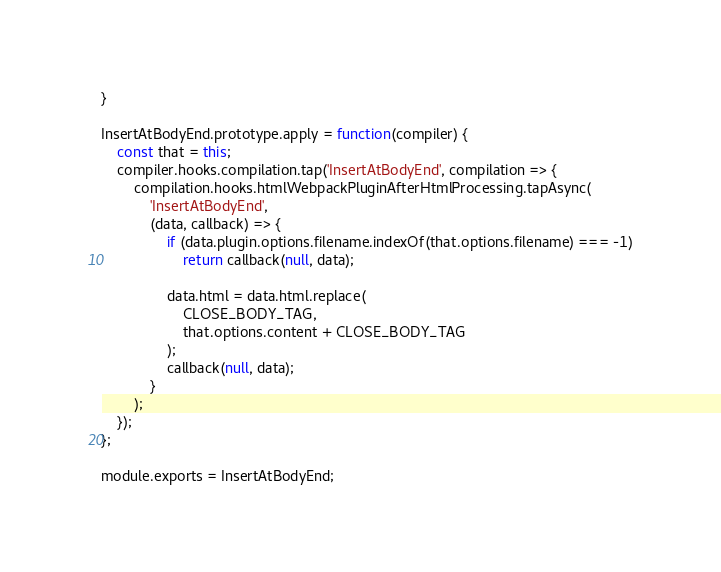<code> <loc_0><loc_0><loc_500><loc_500><_JavaScript_>}

InsertAtBodyEnd.prototype.apply = function(compiler) {
    const that = this;
    compiler.hooks.compilation.tap('InsertAtBodyEnd', compilation => {
        compilation.hooks.htmlWebpackPluginAfterHtmlProcessing.tapAsync(
            'InsertAtBodyEnd',
            (data, callback) => {
                if (data.plugin.options.filename.indexOf(that.options.filename) === -1)
                    return callback(null, data);

                data.html = data.html.replace(
                    CLOSE_BODY_TAG,
                    that.options.content + CLOSE_BODY_TAG
                );
                callback(null, data);
            }
        );
    });
};

module.exports = InsertAtBodyEnd;
</code> 